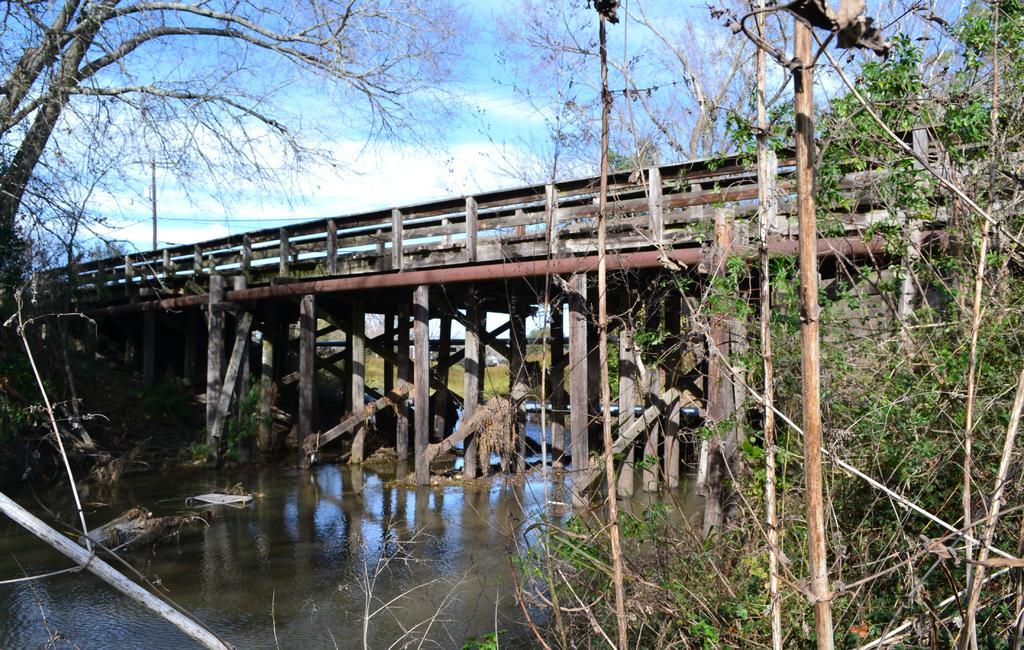Please provide a concise description of this image. In this image I can see bridge on the top of water beside that there are some trees. 